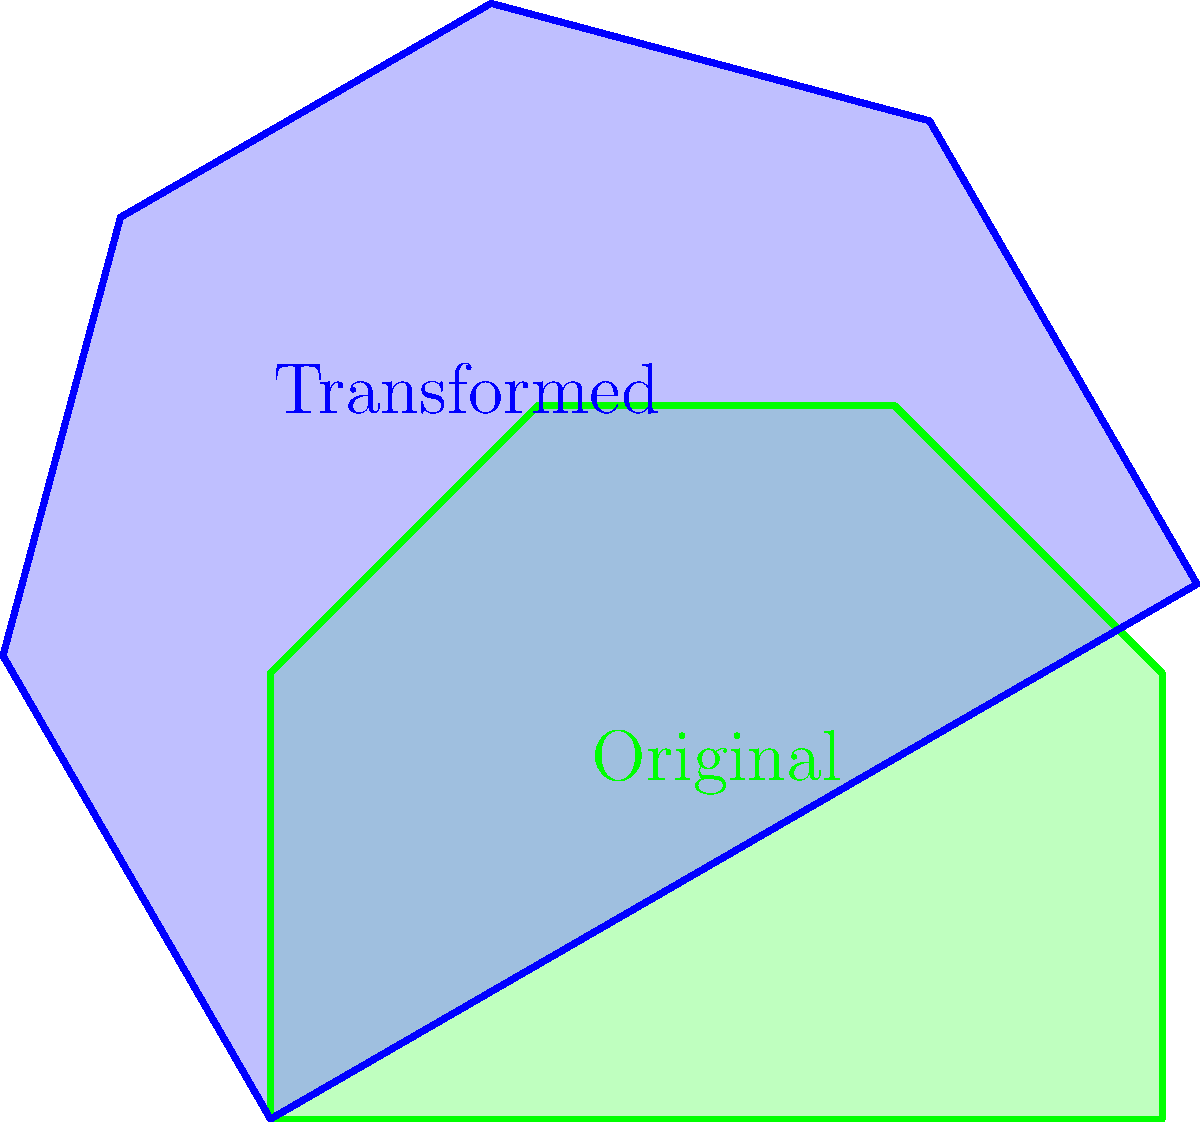In your playing days, you've seen some unique end zone designs. Consider the irregularly shaped end zone shown in green. After a transformation that rotates it 30° clockwise and scales it by a factor of 1.2 (shown in blue), what is the new area of the end zone? Round your answer to the nearest square yard. Let's approach this step-by-step:

1) First, we need to calculate the area of the original end zone. We can split it into a rectangle and a trapezoid:

   Rectangle: $10 \times 5 = 50$ sq yards
   Trapezoid: $\frac{1}{2}(10+0)(8-5) = 15$ sq yards
   Total original area: $50 + 15 = 65$ sq yards

2) The transformation includes a rotation and a scaling. Rotation doesn't affect area, but scaling does.

3) When we scale a 2D shape by a factor of $k$, its area is multiplied by $k^2$.

4) In this case, the scaling factor is 1.2, so the new area will be:

   $65 \times 1.2^2 = 65 \times 1.44 = 93.6$ sq yards

5) Rounding to the nearest square yard, we get 94 sq yards.
Answer: 94 sq yards 